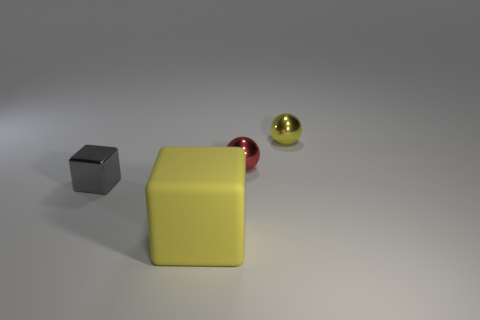Is there anything else that is made of the same material as the big yellow object?
Your answer should be very brief. No. What is the shape of the other small object that is the same color as the rubber object?
Ensure brevity in your answer.  Sphere. What shape is the yellow object that is in front of the tiny object that is on the left side of the big yellow rubber object?
Offer a very short reply. Cube. There is another object that is the same shape as the tiny red shiny thing; what size is it?
Offer a very short reply. Small. Is there any other thing that has the same size as the red thing?
Offer a terse response. Yes. What color is the small metallic thing that is on the left side of the rubber block?
Your answer should be very brief. Gray. The tiny object to the left of the cube that is in front of the block to the left of the big matte thing is made of what material?
Provide a succinct answer. Metal. There is a block right of the metal object that is to the left of the large yellow matte cube; what size is it?
Your answer should be compact. Large. There is another small thing that is the same shape as the matte thing; what color is it?
Give a very brief answer. Gray. How many metal things are the same color as the large matte object?
Offer a terse response. 1. 